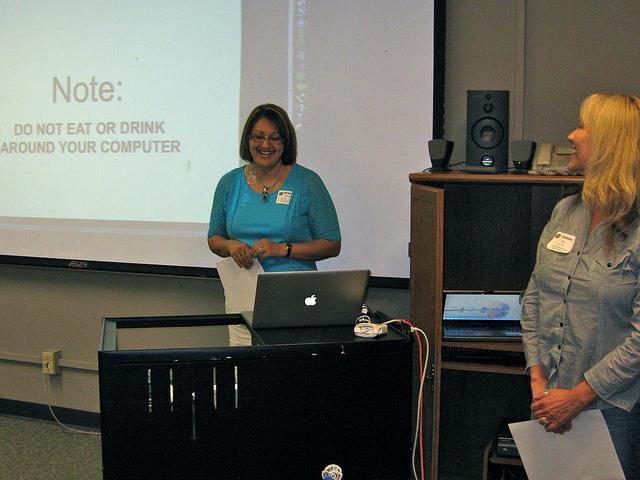Is the woman on the left wearing her hair up or down?
Give a very brief answer. Down. What does it say not to do around the computer?
Write a very short answer. Eat or drink. What type of laptop computer is that?
Be succinct. Apple. What is the woman doing with her hands?
Concise answer only. Holding paper. What is she speaking into?
Give a very brief answer. Nothing. Is this picture at the airport?
Write a very short answer. No. How many people in this image are wearing glasses?
Give a very brief answer. 1. In what language is the note written?
Short answer required. English. Are all the people men?
Answer briefly. No. Who makes the laptops on display?
Give a very brief answer. Apple. What is on top of the table?
Write a very short answer. Laptop. Is there mail on the desk?
Give a very brief answer. No. How many computers are shown?
Keep it brief. 2. Why is this photo so dark?
Quick response, please. Indoors. 